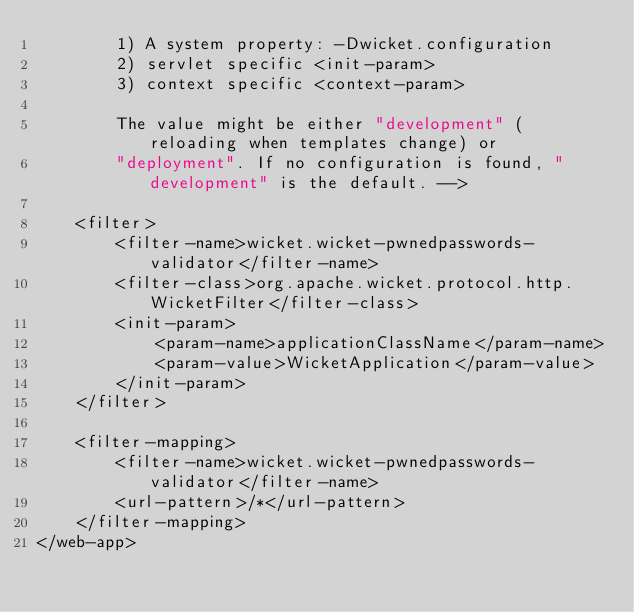Convert code to text. <code><loc_0><loc_0><loc_500><loc_500><_XML_>		1) A system property: -Dwicket.configuration 
		2) servlet specific <init-param> 
		3) context specific <context-param>

		The value might be either "development" (reloading when templates change) or 
		"deployment". If no configuration is found, "development" is the default. -->

	<filter>
		<filter-name>wicket.wicket-pwnedpasswords-validator</filter-name>
		<filter-class>org.apache.wicket.protocol.http.WicketFilter</filter-class>
		<init-param>
			<param-name>applicationClassName</param-name>
			<param-value>WicketApplication</param-value>
		</init-param>
	</filter>

	<filter-mapping>
		<filter-name>wicket.wicket-pwnedpasswords-validator</filter-name>
		<url-pattern>/*</url-pattern>
	</filter-mapping>
</web-app>
</code> 